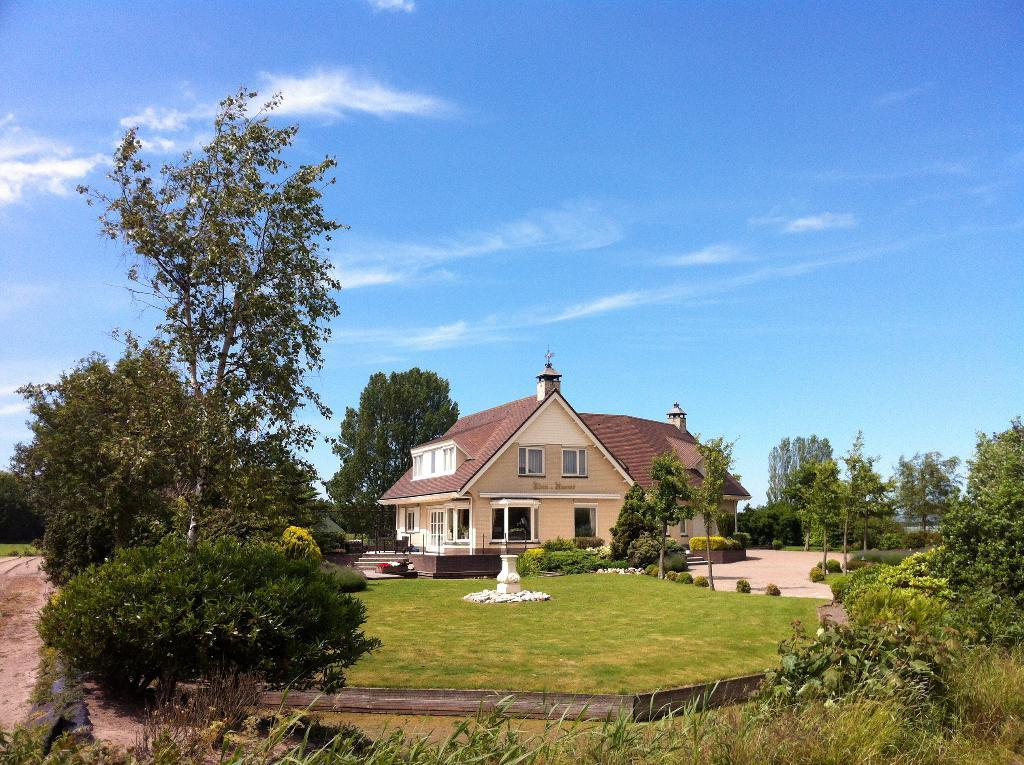What is located at the bottom of the image? There are buildings, trees, plants, and grass at the bottom of the image. What type of vegetation can be seen at the bottom of the image? Trees and plants are visible at the bottom of the image. What is the color of the sky in the background of the image? The sky in the background of the image is blue, with clouds visible. Can you see a giraffe walking through the grass in the image? No, there is no giraffe present in the image. How many knees can be seen on the plants in the image? Plants do not have knees, so this question cannot be answered based on the image. 